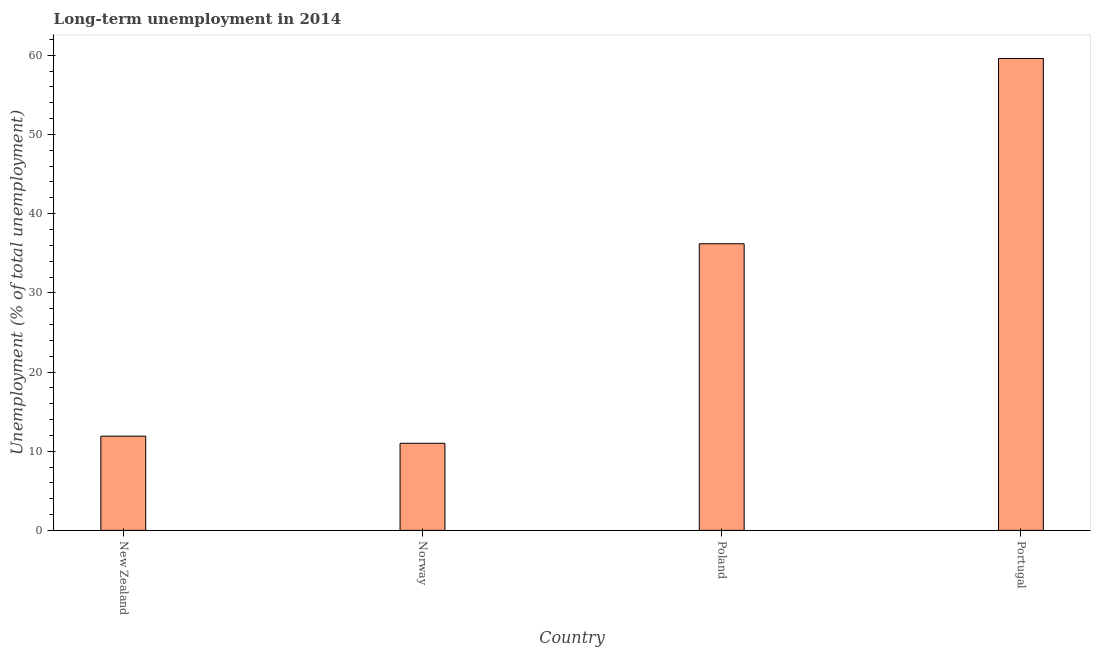Does the graph contain any zero values?
Provide a short and direct response. No. Does the graph contain grids?
Offer a terse response. No. What is the title of the graph?
Offer a very short reply. Long-term unemployment in 2014. What is the label or title of the Y-axis?
Provide a short and direct response. Unemployment (% of total unemployment). What is the long-term unemployment in Poland?
Your response must be concise. 36.2. Across all countries, what is the maximum long-term unemployment?
Your answer should be very brief. 59.6. In which country was the long-term unemployment maximum?
Offer a terse response. Portugal. What is the sum of the long-term unemployment?
Make the answer very short. 118.7. What is the difference between the long-term unemployment in Norway and Poland?
Provide a short and direct response. -25.2. What is the average long-term unemployment per country?
Make the answer very short. 29.68. What is the median long-term unemployment?
Make the answer very short. 24.05. In how many countries, is the long-term unemployment greater than 6 %?
Offer a very short reply. 4. What is the ratio of the long-term unemployment in Norway to that in Poland?
Your response must be concise. 0.3. Is the long-term unemployment in Norway less than that in Poland?
Offer a very short reply. Yes. Is the difference between the long-term unemployment in New Zealand and Norway greater than the difference between any two countries?
Make the answer very short. No. What is the difference between the highest and the second highest long-term unemployment?
Provide a succinct answer. 23.4. What is the difference between the highest and the lowest long-term unemployment?
Your answer should be very brief. 48.6. How many bars are there?
Ensure brevity in your answer.  4. How many countries are there in the graph?
Give a very brief answer. 4. What is the difference between two consecutive major ticks on the Y-axis?
Your answer should be compact. 10. Are the values on the major ticks of Y-axis written in scientific E-notation?
Your answer should be very brief. No. What is the Unemployment (% of total unemployment) of New Zealand?
Your answer should be compact. 11.9. What is the Unemployment (% of total unemployment) in Norway?
Provide a short and direct response. 11. What is the Unemployment (% of total unemployment) of Poland?
Provide a succinct answer. 36.2. What is the Unemployment (% of total unemployment) in Portugal?
Provide a short and direct response. 59.6. What is the difference between the Unemployment (% of total unemployment) in New Zealand and Poland?
Your response must be concise. -24.3. What is the difference between the Unemployment (% of total unemployment) in New Zealand and Portugal?
Keep it short and to the point. -47.7. What is the difference between the Unemployment (% of total unemployment) in Norway and Poland?
Ensure brevity in your answer.  -25.2. What is the difference between the Unemployment (% of total unemployment) in Norway and Portugal?
Provide a short and direct response. -48.6. What is the difference between the Unemployment (% of total unemployment) in Poland and Portugal?
Keep it short and to the point. -23.4. What is the ratio of the Unemployment (% of total unemployment) in New Zealand to that in Norway?
Your response must be concise. 1.08. What is the ratio of the Unemployment (% of total unemployment) in New Zealand to that in Poland?
Provide a succinct answer. 0.33. What is the ratio of the Unemployment (% of total unemployment) in New Zealand to that in Portugal?
Provide a short and direct response. 0.2. What is the ratio of the Unemployment (% of total unemployment) in Norway to that in Poland?
Give a very brief answer. 0.3. What is the ratio of the Unemployment (% of total unemployment) in Norway to that in Portugal?
Offer a very short reply. 0.18. What is the ratio of the Unemployment (% of total unemployment) in Poland to that in Portugal?
Your answer should be very brief. 0.61. 